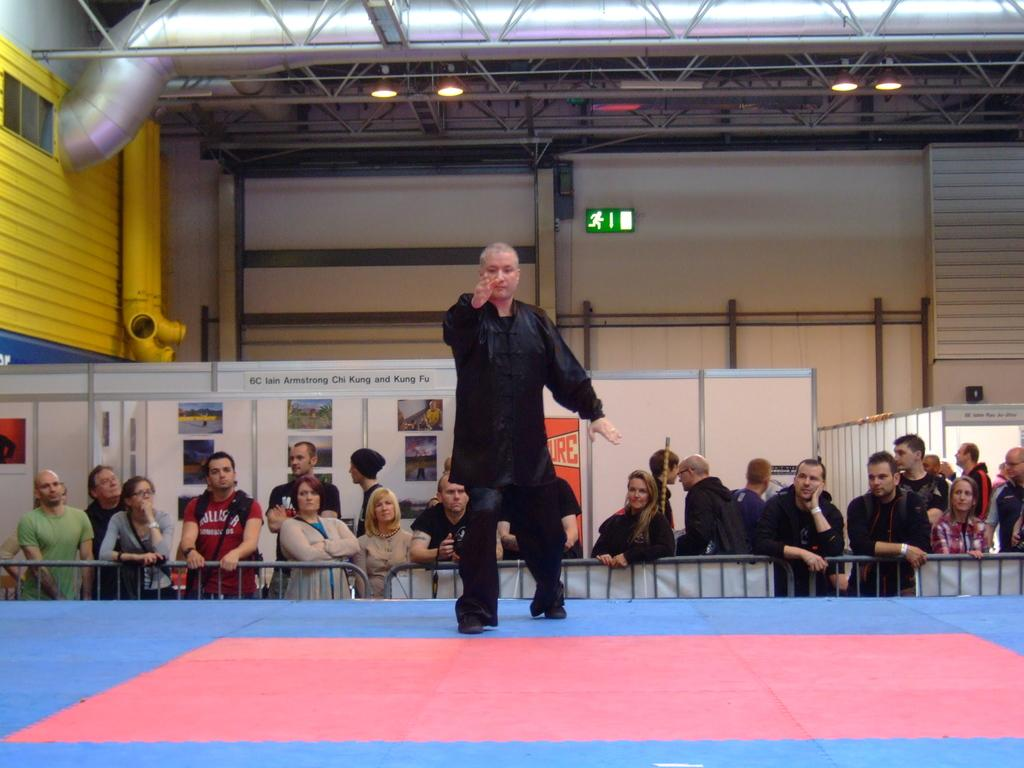What is the main subject of the image? There is a man standing in the center of the image. What can be seen in the background of the image? There are people, a fence, boards, and a wall in the background of the image. Are there any light sources visible in the image? Yes, there are lights visible at the top of the image. What decision is the man making in the image? There is no indication in the image that the man is making a decision. Can you see a basketball court in the image? There is no basketball court visible in the image. 